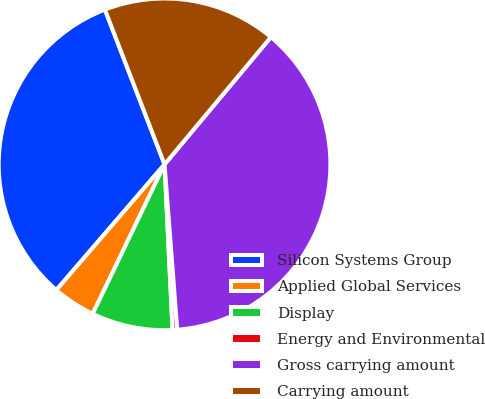<chart> <loc_0><loc_0><loc_500><loc_500><pie_chart><fcel>Silicon Systems Group<fcel>Applied Global Services<fcel>Display<fcel>Energy and Environmental<fcel>Gross carrying amount<fcel>Carrying amount<nl><fcel>32.83%<fcel>4.18%<fcel>7.9%<fcel>0.45%<fcel>37.7%<fcel>16.93%<nl></chart> 